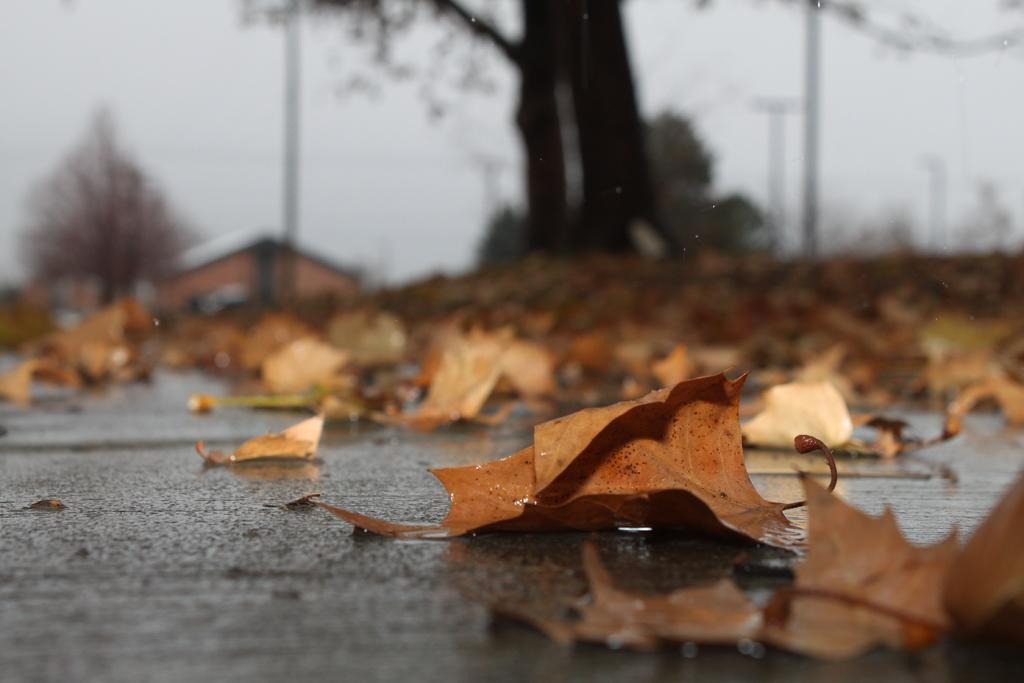What is present on the road in the image? There are leaves on the road in the image. What type of structure can be seen in the image? There is a house in the image. What type of vegetation is present in the image? There are trees in the image. What is visible in the background of the image? The sky is visible in the background of the image. What direction are the trees growing in the image? The direction in which the trees are growing cannot be determined from the image. What type of paste is being used to stick the leaves on the road in the image? There is no indication in the image that any paste is being used to stick the leaves on the road. 